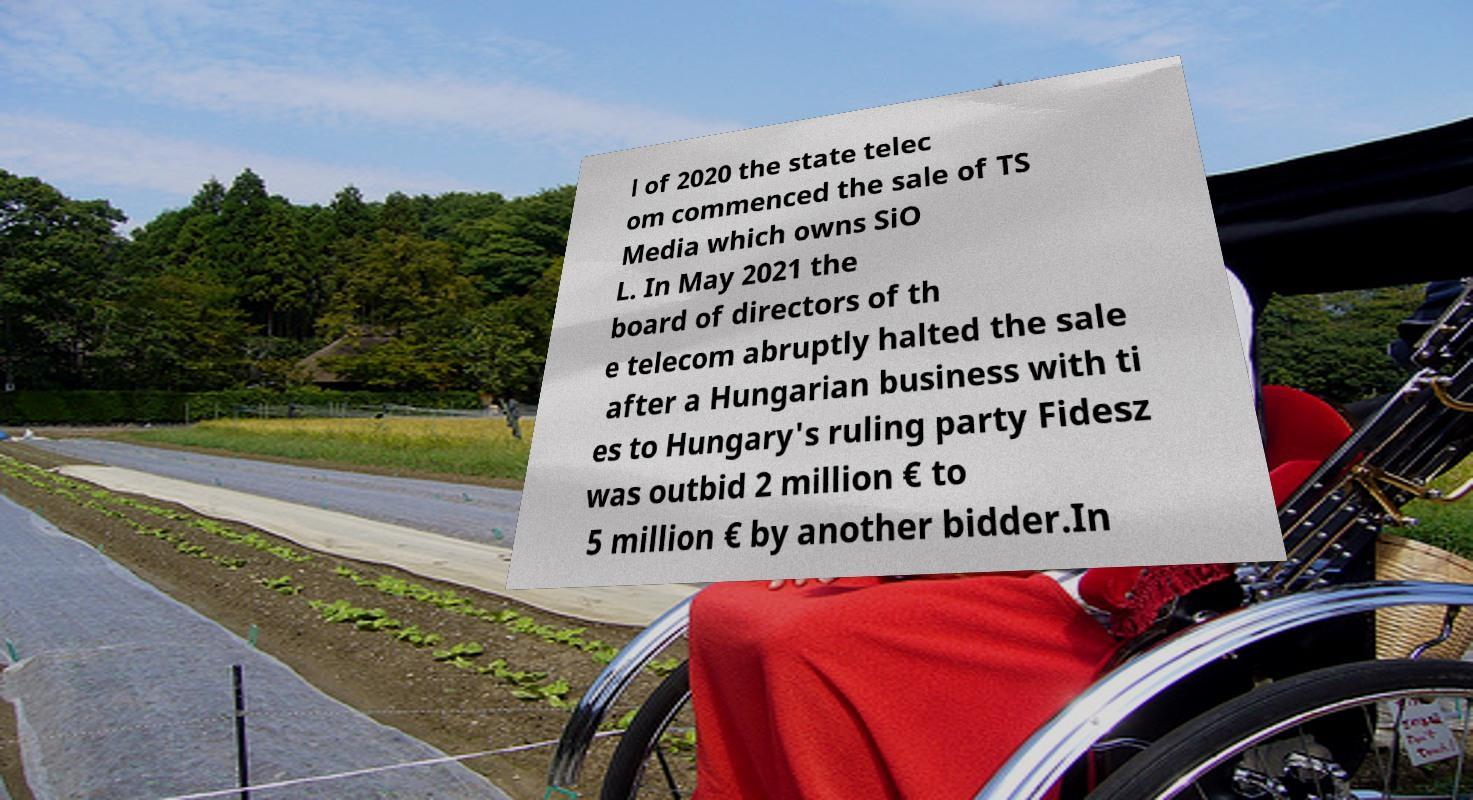For documentation purposes, I need the text within this image transcribed. Could you provide that? l of 2020 the state telec om commenced the sale of TS Media which owns SiO L. In May 2021 the board of directors of th e telecom abruptly halted the sale after a Hungarian business with ti es to Hungary's ruling party Fidesz was outbid 2 million € to 5 million € by another bidder.In 